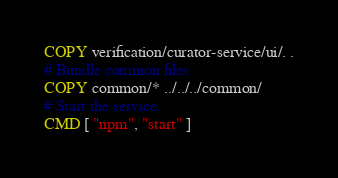Convert code to text. <code><loc_0><loc_0><loc_500><loc_500><_Dockerfile_>COPY verification/curator-service/ui/. .
# Bundle common files
COPY common/* ../../../common/
# Start the service.
CMD [ "npm", "start" ]</code> 